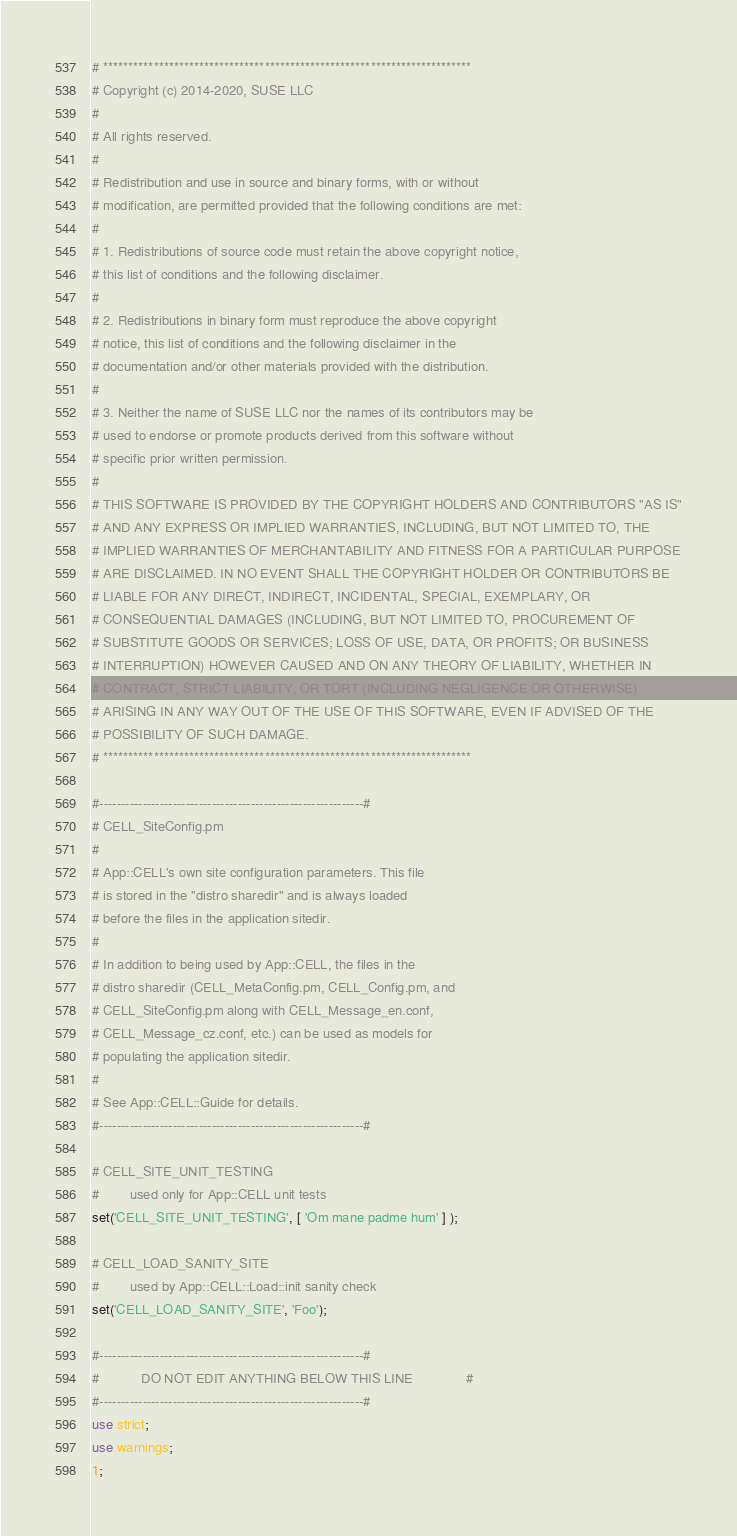<code> <loc_0><loc_0><loc_500><loc_500><_Perl_># ************************************************************************* 
# Copyright (c) 2014-2020, SUSE LLC
# 
# All rights reserved.
# 
# Redistribution and use in source and binary forms, with or without
# modification, are permitted provided that the following conditions are met:
# 
# 1. Redistributions of source code must retain the above copyright notice,
# this list of conditions and the following disclaimer.
# 
# 2. Redistributions in binary form must reproduce the above copyright
# notice, this list of conditions and the following disclaimer in the
# documentation and/or other materials provided with the distribution.
# 
# 3. Neither the name of SUSE LLC nor the names of its contributors may be
# used to endorse or promote products derived from this software without
# specific prior written permission.
# 
# THIS SOFTWARE IS PROVIDED BY THE COPYRIGHT HOLDERS AND CONTRIBUTORS "AS IS"
# AND ANY EXPRESS OR IMPLIED WARRANTIES, INCLUDING, BUT NOT LIMITED TO, THE
# IMPLIED WARRANTIES OF MERCHANTABILITY AND FITNESS FOR A PARTICULAR PURPOSE
# ARE DISCLAIMED. IN NO EVENT SHALL THE COPYRIGHT HOLDER OR CONTRIBUTORS BE
# LIABLE FOR ANY DIRECT, INDIRECT, INCIDENTAL, SPECIAL, EXEMPLARY, OR
# CONSEQUENTIAL DAMAGES (INCLUDING, BUT NOT LIMITED TO, PROCUREMENT OF
# SUBSTITUTE GOODS OR SERVICES; LOSS OF USE, DATA, OR PROFITS; OR BUSINESS
# INTERRUPTION) HOWEVER CAUSED AND ON ANY THEORY OF LIABILITY, WHETHER IN
# CONTRACT, STRICT LIABILITY, OR TORT (INCLUDING NEGLIGENCE OR OTHERWISE)
# ARISING IN ANY WAY OUT OF THE USE OF THIS SOFTWARE, EVEN IF ADVISED OF THE
# POSSIBILITY OF SUCH DAMAGE.
# ************************************************************************* 

#-------------------------------------------------------------#
# CELL_SiteConfig.pm
#
# App::CELL's own site configuration parameters. This file
# is stored in the "distro sharedir" and is always loaded 
# before the files in the application sitedir.
#
# In addition to being used by App::CELL, the files in the
# distro sharedir (CELL_MetaConfig.pm, CELL_Config.pm, and
# CELL_SiteConfig.pm along with CELL_Message_en.conf,
# CELL_Message_cz.conf, etc.) can be used as models for 
# populating the application sitedir.
#
# See App::CELL::Guide for details.
#-------------------------------------------------------------#

# CELL_SITE_UNIT_TESTING
#        used only for App::CELL unit tests
set('CELL_SITE_UNIT_TESTING', [ 'Om mane padme hum' ] );

# CELL_LOAD_SANITY_SITE
#        used by App::CELL::Load::init sanity check
set('CELL_LOAD_SANITY_SITE', 'Foo');

#-------------------------------------------------------------#
#           DO NOT EDIT ANYTHING BELOW THIS LINE              #
#-------------------------------------------------------------#
use strict;
use warnings;
1;
</code> 